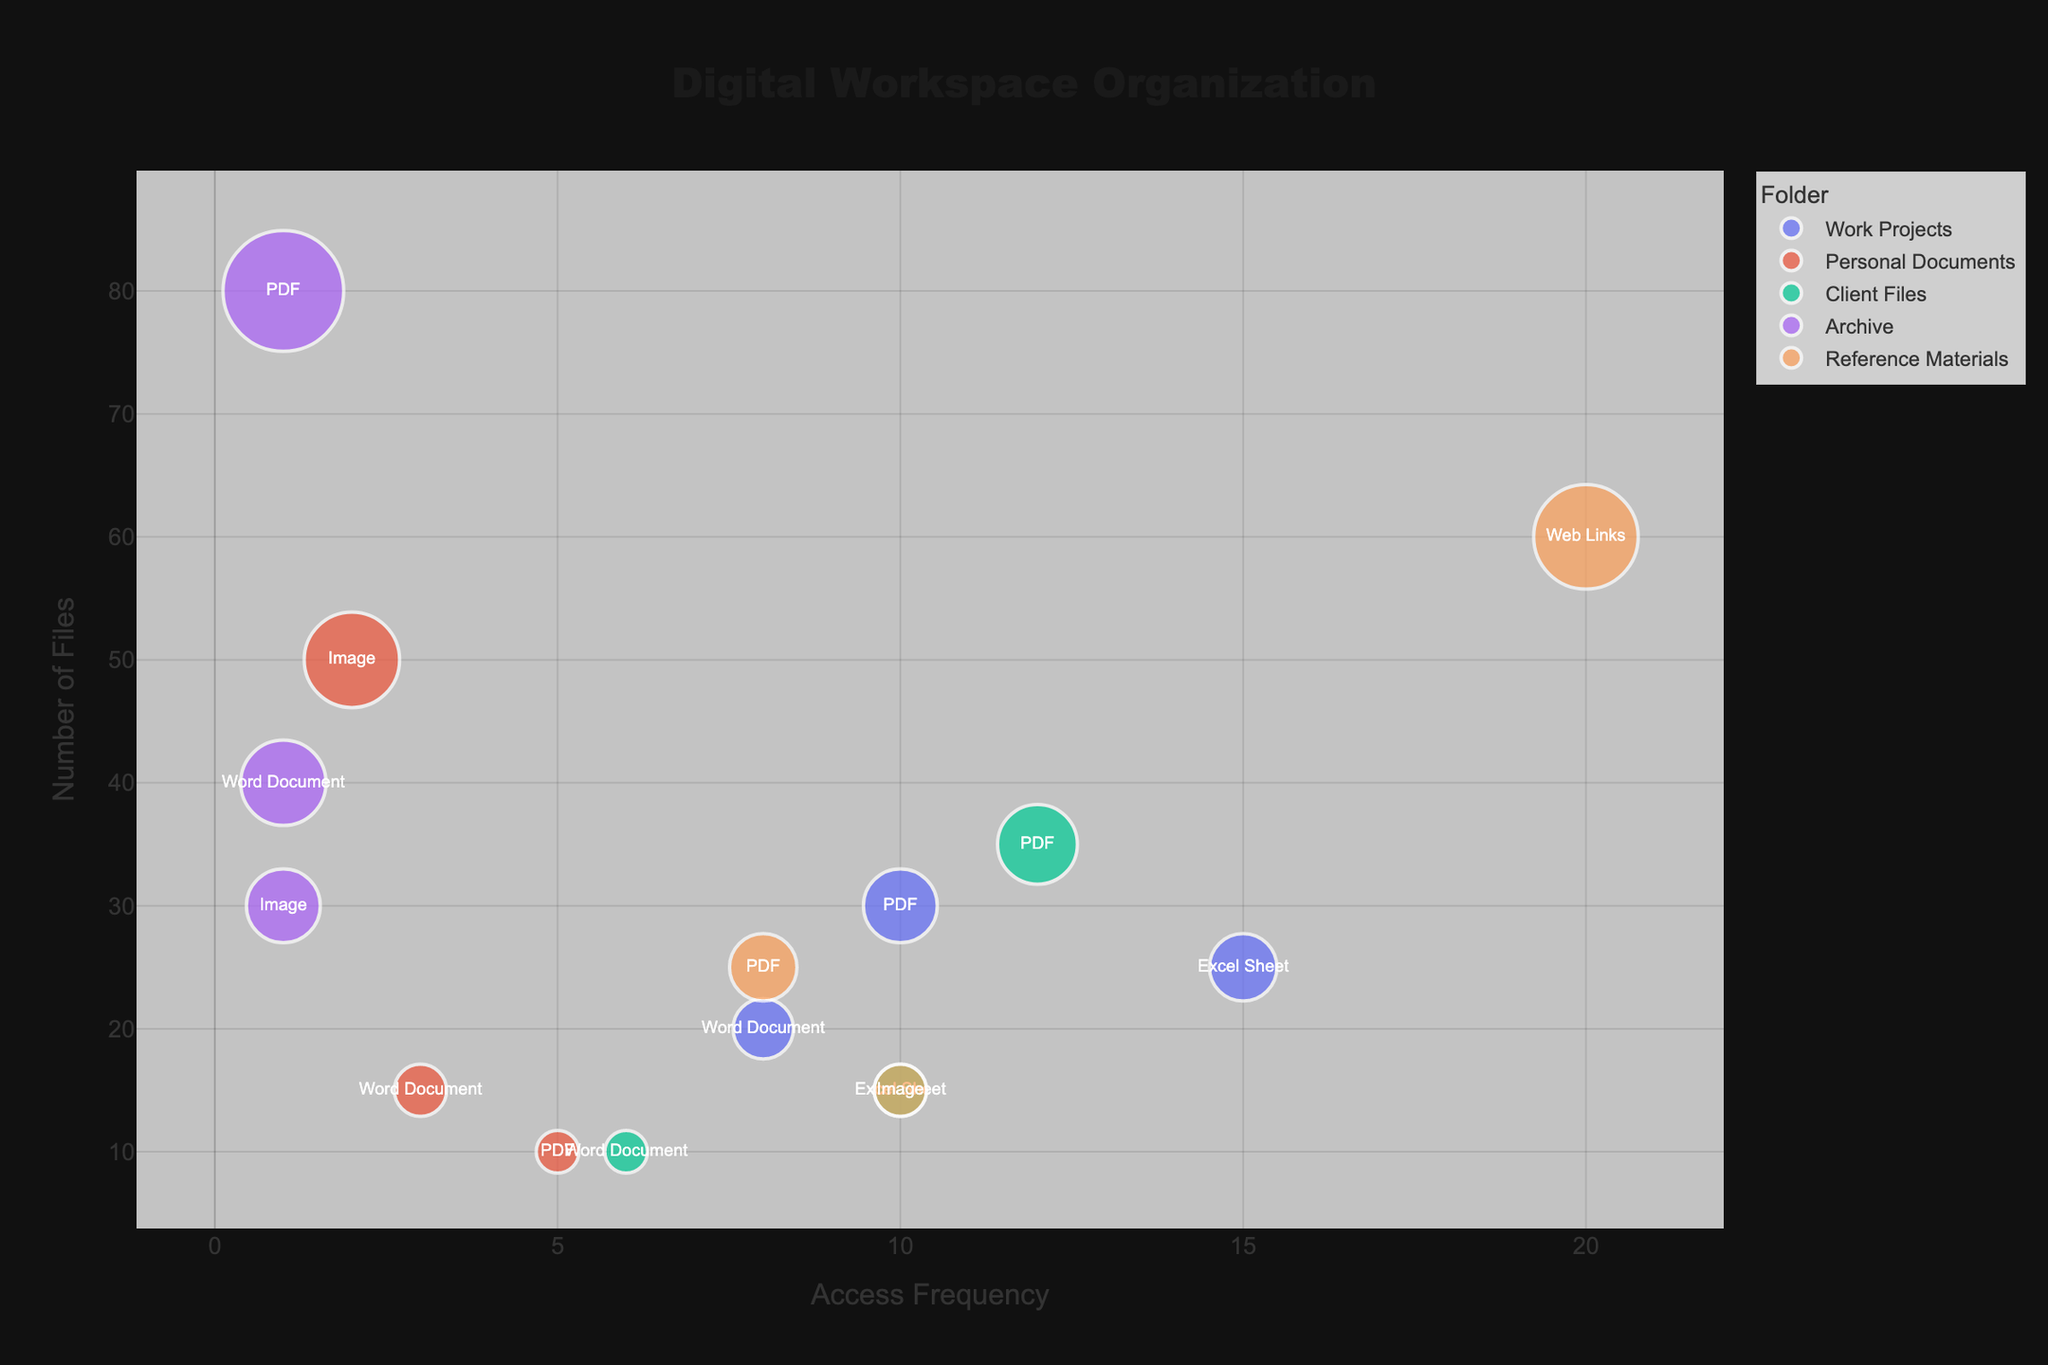What is the title of the chart? The title of the chart is prominently placed at the top of the figure. It is in large, bold font.
Answer: Digital Workspace Organization What are the labels of the x and y axes? The labels of the axes are typically indicated near the axes themselves in a readable font size. The x-axis label is "Access Frequency," and the y-axis label is "Number of Files."
Answer: Access Frequency and Number of Files How many folders are represented in the chart? Folders are differentiated by colors in the chart. By inspecting the legend, we can see the number of distinct colors used to represent various folders.
Answer: 4 Which file type in the "Work Projects" folder has the highest access frequency? By looking at the bubble chart, we can locate the "Work Projects" section and identify the bubble that has the highest position on the x-axis. The file type is indicated by the bubble's label.
Answer: Excel Sheet What is the sum of the number of files for all PDFs across all folders? Locate all the bubbles labeled "PDF" and sum up their corresponding "Number of Files" values: (30 from Work Projects) + (10 from Personal Documents) + (35 from Client Files) + (80 from Archive) + (25 from Reference Materials) = 180.
Answer: 180 Which folder has the file type with the lowest access frequency, and what is the file type? Find the bubble with the lowest value on the x-axis (access frequency) and observe its associated folder and file type by inspecting the legend and bubble's label.
Answer: Archive, (PDF, Word Document, Image) Which has more files, the "Archive" folder or the "Reference Materials" folder? Sum up the number of files for all file types in both folders: Archive (PDF: 80, Word Document: 40, Image: 30) = 150, Reference Materials (PDF: 25, Web Links: 60, Image: 15) = 100. Compare their totals.
Answer: Archive Which folder contains the file type with the highest access frequency, and what is the file type? Look for the bubble located furthest to the right (highest on the x-axis) and identify the associated folder and file type.
Answer: Reference Materials, Web Links Is there a folder with more than one file type having the same access frequency? Inspect the bubbles within each folder and check for instances where multiple bubbles within the same folder share the same x-axis value (access frequency).
Answer: Yes, Archive How does the number of PDF files in "Client Files" compare to the number of PDF files in "Work Projects"? Locate the bubbles corresponding to PDFs within "Client Files" and "Work Projects" and compare their y-axis values: Client Files (35), Work Projects (30).
Answer: Client Files have more PDFs 